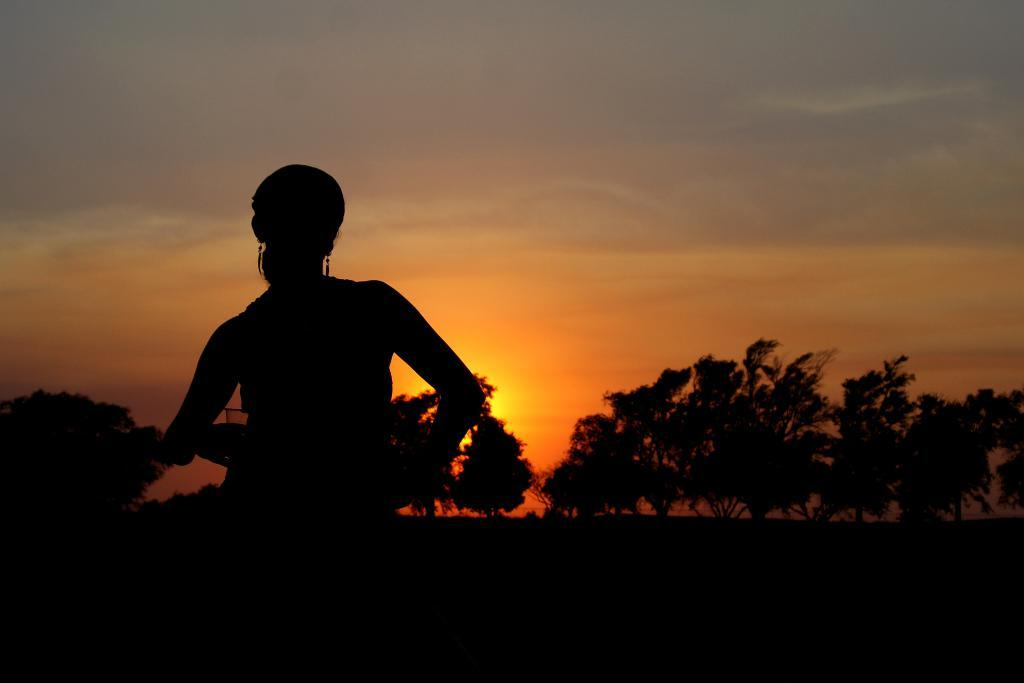Who is the main subject in the image? There is a woman in the image. What is the lighting condition in the image? The woman is standing in a dark environment. What can be seen in the background of the image? There are trees and the sky visible in the background of the image. What is the weather like in the image? Sunshine is present in the sky, suggesting a clear day. What is the name of the railway station in the image? There is no railway station present in the image. What statement does the woman make in the image? The image does not depict any speech or text, so it is not possible to determine what statement the woman might make. 